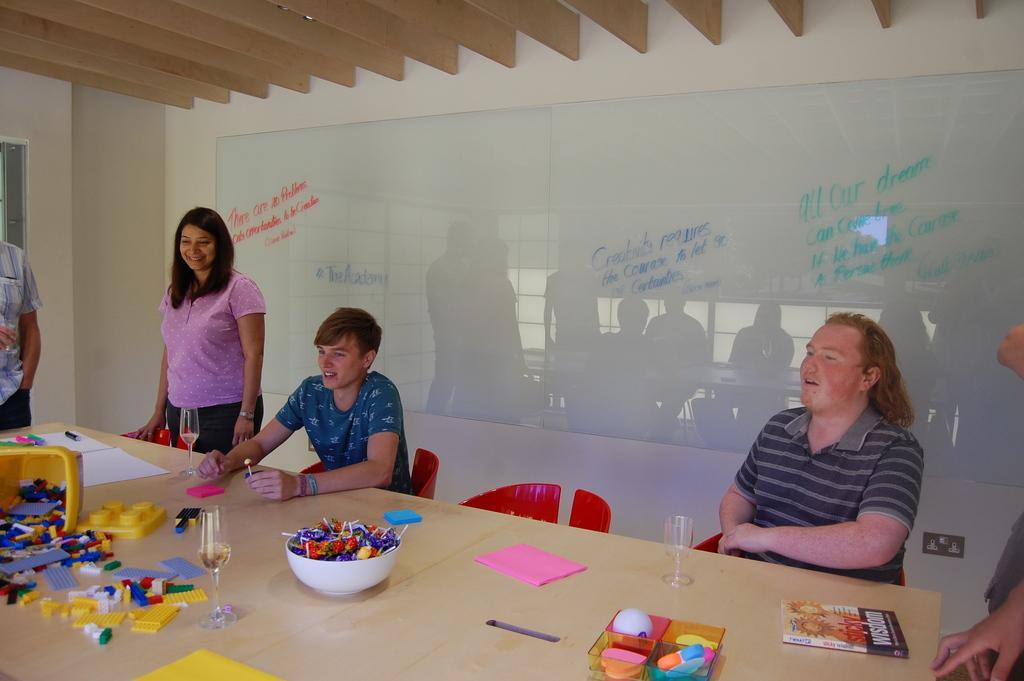Could you give a brief overview of what you see in this image? In the foreground of this image, there is a table on which books, papers, glasses, buildings blocks, objects in a box, a yellow object and a bowl full of lollipops are on it. Around the table, there are persons sitting and standing, red chairs, a white board, wall and the wooden ceiling. 